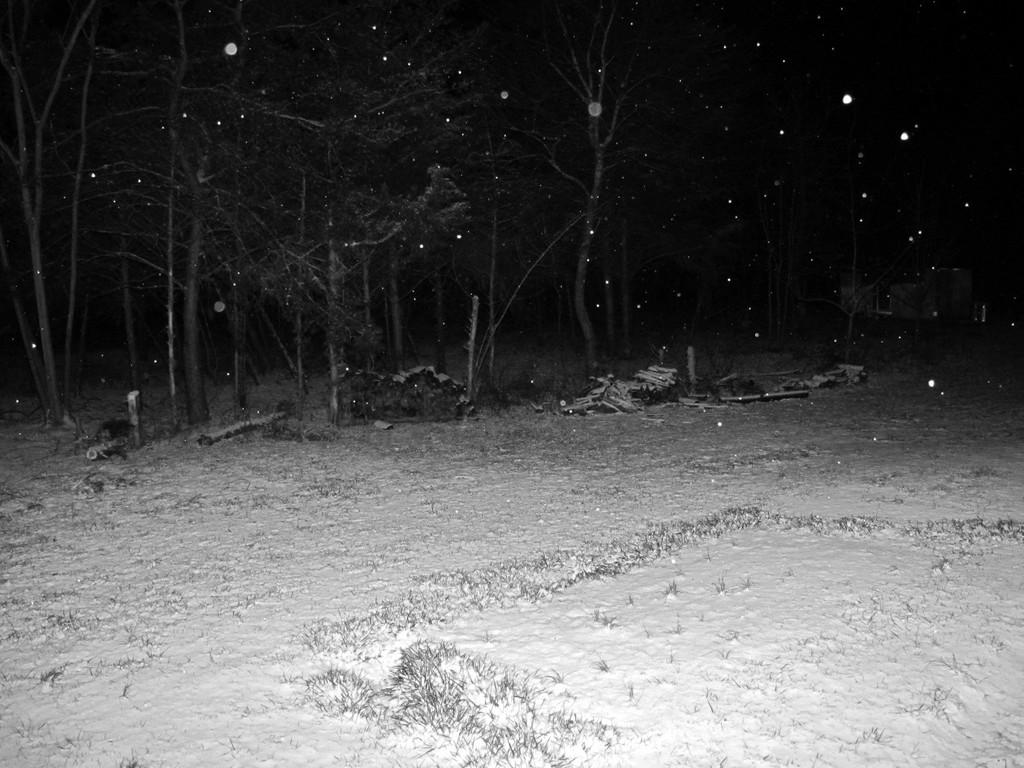What type of vegetation is visible in the image? There is grass in the image. What weather condition is depicted in the image? There is snow in the image. What type of natural structures are present in the image? There are trees in the image. What objects are made of wood in the image? There are wooden sticks in the image. Can you describe the background of the image? The background of the image is dark. What type of dinner is being served in the image? There is no dinner present in the image; it features grass, snow, trees, wooden sticks, and a dark background. 